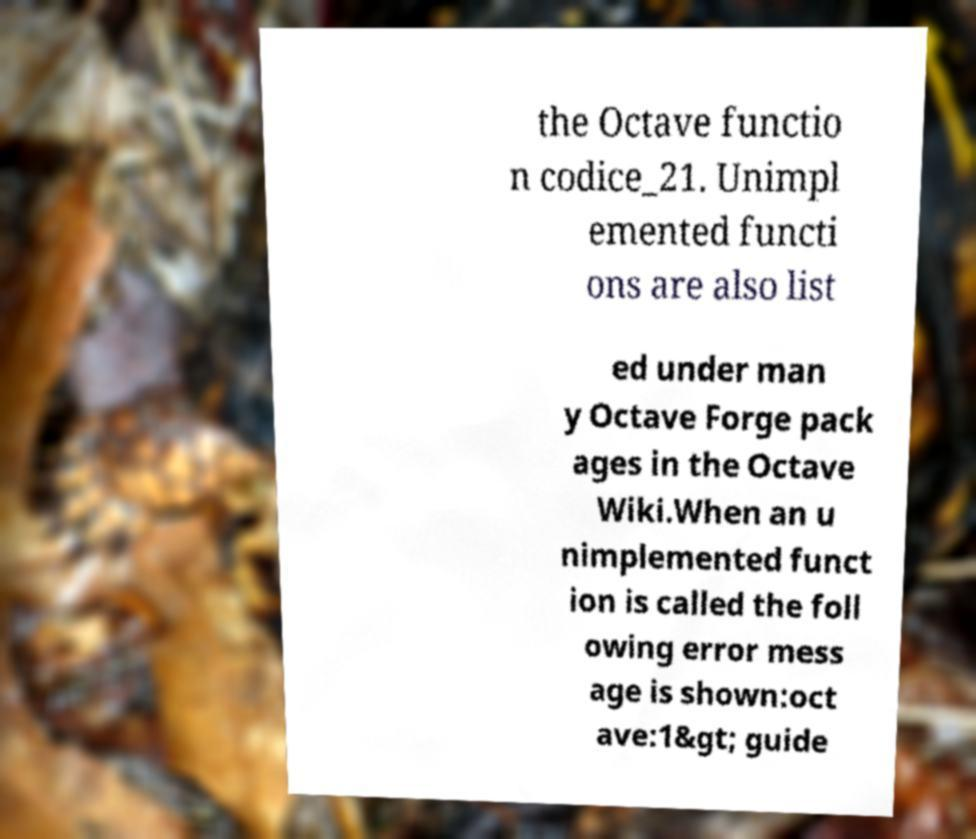For documentation purposes, I need the text within this image transcribed. Could you provide that? the Octave functio n codice_21. Unimpl emented functi ons are also list ed under man y Octave Forge pack ages in the Octave Wiki.When an u nimplemented funct ion is called the foll owing error mess age is shown:oct ave:1&gt; guide 